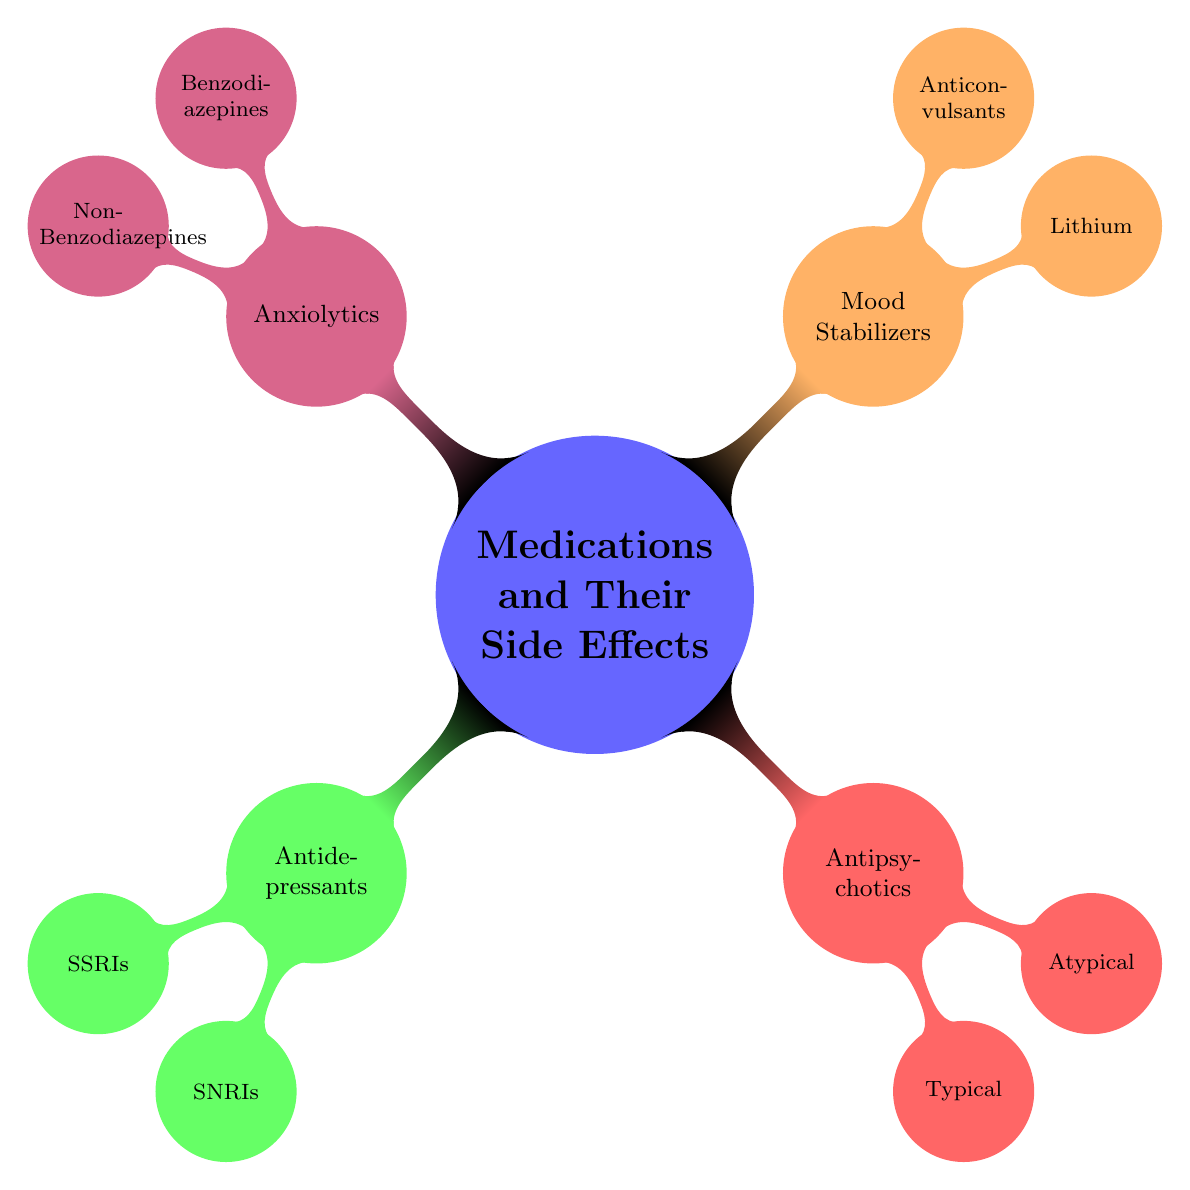What are the two main categories of medications in the diagram? The diagram has four main categories of medications: Antidepressants, Antipsychotics, Mood Stabilizers, and Anxiolytics. The two categories specifically asked are Antidepressants and Antipsychotics.
Answer: Antidepressants, Antipsychotics How many types of antidepressants are listed? The diagram mentions two types of antidepressants: SSRIs and SNRIs.
Answer: 2 What common side effect is associated with typical antipsychotics? The node for Typical Antipsychotics lists three common side effects, one of which is Tardive Dyskinesia.
Answer: Tardive Dyskinesia Which medication class has a risk of diabetes as a side effect? The Atypical Antipsychotics node indicates that one common side effect is Diabetes Risk, meaning this class is associated with it.
Answer: Atypical Antipsychotics What are the common side effects of mood stabilizers listed in the diagram? The Mood Stabilizers section presents Lithium and Anticonvulsants. For Lithium, the common side effects are Tremors, Thirst, and Nausea, while Anticonvulsants have Dizziness, Rash, and Weight Gain.
Answer: Tremors, Thirst, Nausea; Dizziness, Rash, Weight Gain Which class of anxiolytics includes Diazepam? The Benzodiazepines node under Anxiolytics lists Diazepam as one of its drugs.
Answer: Benzodiazepines How many drugs are listed under SSRIs? The SSRIs node includes three specific drugs: Fluoxetine, Sertraline, and Citalopram. Counting these gives a total of three drugs.
Answer: 3 What common side effect do both SSRIs and SNRIs share? Both SSRIs and SNRIs are antidepressants, and they share the side effect of Nausea, which appears in the SSRIs section.
Answer: Nausea 